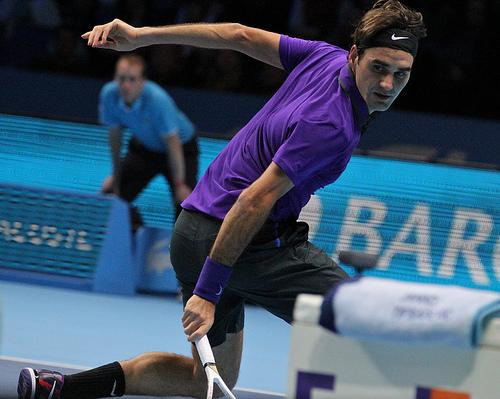Please count the number of tennis rackets and wristbands in the image. There is one tennis racket and one purple wristband in the image. What brand is the headband the man is wearing, and what logo is on it? The man is wearing a black and white Nike headband with a white Nike logo. Describe the interaction between the main tennis player and the man in the background. The main tennis player is focused on the game, while the man in the background is observing and judging the match. What colors make up the tennis court's background elements and surroundings? The background consists of blue, white, and a minimal presence of red colors. In a brief sentence, describe the man observing the tennis match. The man in a light blue shirt is bending at the knees and watching the tennis match. What sport is the man primarily engaged in? The man is primarily engaged in playing tennis. Analyze the image sentiment and describe the overall tone or mood of the scene. The image has a competitive and athletic mood, with a focus on a tennis match and sporty attire. Identify the color and type of clothing the tennis player is wearing. The tennis player is wearing a purple shirt, black shorts, and black socks. Find the tennis ball flying towards the player. There is no mention of a tennis ball in the given image information. This will make the user search for something that is not in the image. Notice the green grass surrounding the tennis court. The image information doesn't mention any grass, green or otherwise. This instruction will have the user searching for non-existent elements in the image. Can you locate the pink umbrella near the tennis court? There's no mention of a pink umbrella in the given image information. Asking the user to find something nonexistent can cause confusion. Is there a water bottle on the ground next to the tennis player? There's no information about a water bottle in the image information provided. By using a question, this instruction may confuse the user and make them try to find something that doesn't exist. Spot the dog running across the tennis court. None of the given image information states anything about a dog being present. This misleading instruction will have the user searching for an object that doesn't exist. Identify the woman in a red dress cheering for the tennis player. The image information doesn't mention a woman or a red dress. This instruction is misleading because it adds elements not present in the image. 